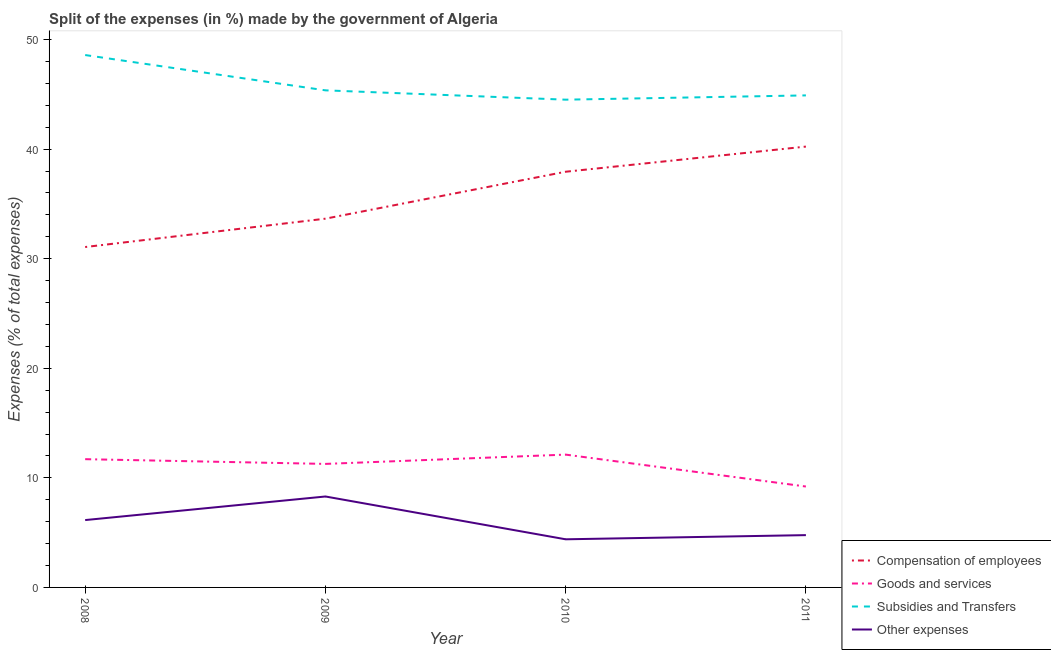How many different coloured lines are there?
Ensure brevity in your answer.  4. Is the number of lines equal to the number of legend labels?
Make the answer very short. Yes. What is the percentage of amount spent on other expenses in 2010?
Provide a succinct answer. 4.39. Across all years, what is the maximum percentage of amount spent on goods and services?
Provide a short and direct response. 12.12. Across all years, what is the minimum percentage of amount spent on goods and services?
Ensure brevity in your answer.  9.21. In which year was the percentage of amount spent on other expenses maximum?
Your response must be concise. 2009. In which year was the percentage of amount spent on compensation of employees minimum?
Your response must be concise. 2008. What is the total percentage of amount spent on compensation of employees in the graph?
Your response must be concise. 142.9. What is the difference between the percentage of amount spent on compensation of employees in 2008 and that in 2011?
Make the answer very short. -9.17. What is the difference between the percentage of amount spent on other expenses in 2008 and the percentage of amount spent on compensation of employees in 2010?
Offer a very short reply. -31.79. What is the average percentage of amount spent on subsidies per year?
Offer a terse response. 45.85. In the year 2011, what is the difference between the percentage of amount spent on subsidies and percentage of amount spent on other expenses?
Offer a very short reply. 40.13. What is the ratio of the percentage of amount spent on subsidies in 2009 to that in 2011?
Your answer should be very brief. 1.01. What is the difference between the highest and the second highest percentage of amount spent on compensation of employees?
Give a very brief answer. 2.29. What is the difference between the highest and the lowest percentage of amount spent on other expenses?
Provide a short and direct response. 3.91. Is it the case that in every year, the sum of the percentage of amount spent on compensation of employees and percentage of amount spent on goods and services is greater than the percentage of amount spent on subsidies?
Your response must be concise. No. Is the percentage of amount spent on goods and services strictly less than the percentage of amount spent on subsidies over the years?
Keep it short and to the point. Yes. Are the values on the major ticks of Y-axis written in scientific E-notation?
Offer a terse response. No. Does the graph contain any zero values?
Provide a succinct answer. No. Does the graph contain grids?
Your answer should be compact. No. What is the title of the graph?
Provide a succinct answer. Split of the expenses (in %) made by the government of Algeria. Does "Secondary" appear as one of the legend labels in the graph?
Your answer should be very brief. No. What is the label or title of the Y-axis?
Make the answer very short. Expenses (% of total expenses). What is the Expenses (% of total expenses) of Compensation of employees in 2008?
Your answer should be very brief. 31.07. What is the Expenses (% of total expenses) of Goods and services in 2008?
Your answer should be very brief. 11.7. What is the Expenses (% of total expenses) in Subsidies and Transfers in 2008?
Ensure brevity in your answer.  48.59. What is the Expenses (% of total expenses) in Other expenses in 2008?
Offer a very short reply. 6.15. What is the Expenses (% of total expenses) of Compensation of employees in 2009?
Your response must be concise. 33.66. What is the Expenses (% of total expenses) in Goods and services in 2009?
Provide a short and direct response. 11.27. What is the Expenses (% of total expenses) of Subsidies and Transfers in 2009?
Your answer should be compact. 45.37. What is the Expenses (% of total expenses) of Other expenses in 2009?
Your answer should be very brief. 8.3. What is the Expenses (% of total expenses) of Compensation of employees in 2010?
Provide a succinct answer. 37.94. What is the Expenses (% of total expenses) in Goods and services in 2010?
Your answer should be compact. 12.12. What is the Expenses (% of total expenses) of Subsidies and Transfers in 2010?
Offer a terse response. 44.52. What is the Expenses (% of total expenses) in Other expenses in 2010?
Your answer should be compact. 4.39. What is the Expenses (% of total expenses) in Compensation of employees in 2011?
Keep it short and to the point. 40.23. What is the Expenses (% of total expenses) in Goods and services in 2011?
Your answer should be compact. 9.21. What is the Expenses (% of total expenses) in Subsidies and Transfers in 2011?
Keep it short and to the point. 44.91. What is the Expenses (% of total expenses) in Other expenses in 2011?
Offer a very short reply. 4.77. Across all years, what is the maximum Expenses (% of total expenses) in Compensation of employees?
Your answer should be compact. 40.23. Across all years, what is the maximum Expenses (% of total expenses) of Goods and services?
Give a very brief answer. 12.12. Across all years, what is the maximum Expenses (% of total expenses) in Subsidies and Transfers?
Your response must be concise. 48.59. Across all years, what is the maximum Expenses (% of total expenses) of Other expenses?
Ensure brevity in your answer.  8.3. Across all years, what is the minimum Expenses (% of total expenses) of Compensation of employees?
Offer a terse response. 31.07. Across all years, what is the minimum Expenses (% of total expenses) of Goods and services?
Provide a succinct answer. 9.21. Across all years, what is the minimum Expenses (% of total expenses) of Subsidies and Transfers?
Keep it short and to the point. 44.52. Across all years, what is the minimum Expenses (% of total expenses) in Other expenses?
Provide a short and direct response. 4.39. What is the total Expenses (% of total expenses) in Compensation of employees in the graph?
Your answer should be very brief. 142.9. What is the total Expenses (% of total expenses) of Goods and services in the graph?
Make the answer very short. 44.31. What is the total Expenses (% of total expenses) in Subsidies and Transfers in the graph?
Your answer should be very brief. 183.38. What is the total Expenses (% of total expenses) in Other expenses in the graph?
Your answer should be compact. 23.61. What is the difference between the Expenses (% of total expenses) in Compensation of employees in 2008 and that in 2009?
Offer a terse response. -2.59. What is the difference between the Expenses (% of total expenses) in Goods and services in 2008 and that in 2009?
Keep it short and to the point. 0.43. What is the difference between the Expenses (% of total expenses) of Subsidies and Transfers in 2008 and that in 2009?
Provide a succinct answer. 3.22. What is the difference between the Expenses (% of total expenses) of Other expenses in 2008 and that in 2009?
Ensure brevity in your answer.  -2.15. What is the difference between the Expenses (% of total expenses) in Compensation of employees in 2008 and that in 2010?
Offer a terse response. -6.87. What is the difference between the Expenses (% of total expenses) in Goods and services in 2008 and that in 2010?
Provide a short and direct response. -0.42. What is the difference between the Expenses (% of total expenses) of Subsidies and Transfers in 2008 and that in 2010?
Your answer should be compact. 4.07. What is the difference between the Expenses (% of total expenses) in Other expenses in 2008 and that in 2010?
Your answer should be very brief. 1.75. What is the difference between the Expenses (% of total expenses) of Compensation of employees in 2008 and that in 2011?
Provide a succinct answer. -9.17. What is the difference between the Expenses (% of total expenses) in Goods and services in 2008 and that in 2011?
Your response must be concise. 2.5. What is the difference between the Expenses (% of total expenses) of Subsidies and Transfers in 2008 and that in 2011?
Provide a short and direct response. 3.68. What is the difference between the Expenses (% of total expenses) of Other expenses in 2008 and that in 2011?
Provide a succinct answer. 1.37. What is the difference between the Expenses (% of total expenses) in Compensation of employees in 2009 and that in 2010?
Your response must be concise. -4.28. What is the difference between the Expenses (% of total expenses) in Goods and services in 2009 and that in 2010?
Provide a short and direct response. -0.85. What is the difference between the Expenses (% of total expenses) in Subsidies and Transfers in 2009 and that in 2010?
Offer a very short reply. 0.85. What is the difference between the Expenses (% of total expenses) in Other expenses in 2009 and that in 2010?
Your answer should be very brief. 3.91. What is the difference between the Expenses (% of total expenses) of Compensation of employees in 2009 and that in 2011?
Your answer should be compact. -6.58. What is the difference between the Expenses (% of total expenses) in Goods and services in 2009 and that in 2011?
Your answer should be very brief. 2.06. What is the difference between the Expenses (% of total expenses) of Subsidies and Transfers in 2009 and that in 2011?
Make the answer very short. 0.46. What is the difference between the Expenses (% of total expenses) of Other expenses in 2009 and that in 2011?
Provide a succinct answer. 3.53. What is the difference between the Expenses (% of total expenses) of Compensation of employees in 2010 and that in 2011?
Make the answer very short. -2.29. What is the difference between the Expenses (% of total expenses) in Goods and services in 2010 and that in 2011?
Your answer should be compact. 2.91. What is the difference between the Expenses (% of total expenses) of Subsidies and Transfers in 2010 and that in 2011?
Offer a very short reply. -0.39. What is the difference between the Expenses (% of total expenses) of Other expenses in 2010 and that in 2011?
Give a very brief answer. -0.38. What is the difference between the Expenses (% of total expenses) in Compensation of employees in 2008 and the Expenses (% of total expenses) in Goods and services in 2009?
Provide a succinct answer. 19.79. What is the difference between the Expenses (% of total expenses) of Compensation of employees in 2008 and the Expenses (% of total expenses) of Subsidies and Transfers in 2009?
Your answer should be very brief. -14.3. What is the difference between the Expenses (% of total expenses) of Compensation of employees in 2008 and the Expenses (% of total expenses) of Other expenses in 2009?
Ensure brevity in your answer.  22.77. What is the difference between the Expenses (% of total expenses) of Goods and services in 2008 and the Expenses (% of total expenses) of Subsidies and Transfers in 2009?
Provide a succinct answer. -33.66. What is the difference between the Expenses (% of total expenses) in Goods and services in 2008 and the Expenses (% of total expenses) in Other expenses in 2009?
Provide a short and direct response. 3.41. What is the difference between the Expenses (% of total expenses) in Subsidies and Transfers in 2008 and the Expenses (% of total expenses) in Other expenses in 2009?
Make the answer very short. 40.29. What is the difference between the Expenses (% of total expenses) of Compensation of employees in 2008 and the Expenses (% of total expenses) of Goods and services in 2010?
Provide a succinct answer. 18.95. What is the difference between the Expenses (% of total expenses) in Compensation of employees in 2008 and the Expenses (% of total expenses) in Subsidies and Transfers in 2010?
Give a very brief answer. -13.45. What is the difference between the Expenses (% of total expenses) of Compensation of employees in 2008 and the Expenses (% of total expenses) of Other expenses in 2010?
Provide a short and direct response. 26.67. What is the difference between the Expenses (% of total expenses) of Goods and services in 2008 and the Expenses (% of total expenses) of Subsidies and Transfers in 2010?
Your answer should be compact. -32.81. What is the difference between the Expenses (% of total expenses) in Goods and services in 2008 and the Expenses (% of total expenses) in Other expenses in 2010?
Provide a succinct answer. 7.31. What is the difference between the Expenses (% of total expenses) in Subsidies and Transfers in 2008 and the Expenses (% of total expenses) in Other expenses in 2010?
Make the answer very short. 44.2. What is the difference between the Expenses (% of total expenses) in Compensation of employees in 2008 and the Expenses (% of total expenses) in Goods and services in 2011?
Ensure brevity in your answer.  21.86. What is the difference between the Expenses (% of total expenses) in Compensation of employees in 2008 and the Expenses (% of total expenses) in Subsidies and Transfers in 2011?
Keep it short and to the point. -13.84. What is the difference between the Expenses (% of total expenses) of Compensation of employees in 2008 and the Expenses (% of total expenses) of Other expenses in 2011?
Keep it short and to the point. 26.29. What is the difference between the Expenses (% of total expenses) in Goods and services in 2008 and the Expenses (% of total expenses) in Subsidies and Transfers in 2011?
Offer a very short reply. -33.2. What is the difference between the Expenses (% of total expenses) of Goods and services in 2008 and the Expenses (% of total expenses) of Other expenses in 2011?
Offer a terse response. 6.93. What is the difference between the Expenses (% of total expenses) of Subsidies and Transfers in 2008 and the Expenses (% of total expenses) of Other expenses in 2011?
Give a very brief answer. 43.82. What is the difference between the Expenses (% of total expenses) of Compensation of employees in 2009 and the Expenses (% of total expenses) of Goods and services in 2010?
Your answer should be very brief. 21.53. What is the difference between the Expenses (% of total expenses) in Compensation of employees in 2009 and the Expenses (% of total expenses) in Subsidies and Transfers in 2010?
Your response must be concise. -10.86. What is the difference between the Expenses (% of total expenses) of Compensation of employees in 2009 and the Expenses (% of total expenses) of Other expenses in 2010?
Keep it short and to the point. 29.26. What is the difference between the Expenses (% of total expenses) in Goods and services in 2009 and the Expenses (% of total expenses) in Subsidies and Transfers in 2010?
Provide a succinct answer. -33.24. What is the difference between the Expenses (% of total expenses) in Goods and services in 2009 and the Expenses (% of total expenses) in Other expenses in 2010?
Ensure brevity in your answer.  6.88. What is the difference between the Expenses (% of total expenses) of Subsidies and Transfers in 2009 and the Expenses (% of total expenses) of Other expenses in 2010?
Provide a succinct answer. 40.97. What is the difference between the Expenses (% of total expenses) in Compensation of employees in 2009 and the Expenses (% of total expenses) in Goods and services in 2011?
Offer a very short reply. 24.45. What is the difference between the Expenses (% of total expenses) in Compensation of employees in 2009 and the Expenses (% of total expenses) in Subsidies and Transfers in 2011?
Offer a very short reply. -11.25. What is the difference between the Expenses (% of total expenses) of Compensation of employees in 2009 and the Expenses (% of total expenses) of Other expenses in 2011?
Offer a terse response. 28.88. What is the difference between the Expenses (% of total expenses) of Goods and services in 2009 and the Expenses (% of total expenses) of Subsidies and Transfers in 2011?
Give a very brief answer. -33.63. What is the difference between the Expenses (% of total expenses) in Goods and services in 2009 and the Expenses (% of total expenses) in Other expenses in 2011?
Make the answer very short. 6.5. What is the difference between the Expenses (% of total expenses) of Subsidies and Transfers in 2009 and the Expenses (% of total expenses) of Other expenses in 2011?
Provide a succinct answer. 40.59. What is the difference between the Expenses (% of total expenses) of Compensation of employees in 2010 and the Expenses (% of total expenses) of Goods and services in 2011?
Your response must be concise. 28.73. What is the difference between the Expenses (% of total expenses) in Compensation of employees in 2010 and the Expenses (% of total expenses) in Subsidies and Transfers in 2011?
Keep it short and to the point. -6.97. What is the difference between the Expenses (% of total expenses) in Compensation of employees in 2010 and the Expenses (% of total expenses) in Other expenses in 2011?
Provide a succinct answer. 33.17. What is the difference between the Expenses (% of total expenses) in Goods and services in 2010 and the Expenses (% of total expenses) in Subsidies and Transfers in 2011?
Your answer should be compact. -32.79. What is the difference between the Expenses (% of total expenses) of Goods and services in 2010 and the Expenses (% of total expenses) of Other expenses in 2011?
Give a very brief answer. 7.35. What is the difference between the Expenses (% of total expenses) in Subsidies and Transfers in 2010 and the Expenses (% of total expenses) in Other expenses in 2011?
Offer a terse response. 39.74. What is the average Expenses (% of total expenses) of Compensation of employees per year?
Ensure brevity in your answer.  35.72. What is the average Expenses (% of total expenses) in Goods and services per year?
Your answer should be compact. 11.08. What is the average Expenses (% of total expenses) of Subsidies and Transfers per year?
Keep it short and to the point. 45.85. What is the average Expenses (% of total expenses) in Other expenses per year?
Your answer should be very brief. 5.9. In the year 2008, what is the difference between the Expenses (% of total expenses) of Compensation of employees and Expenses (% of total expenses) of Goods and services?
Your answer should be compact. 19.36. In the year 2008, what is the difference between the Expenses (% of total expenses) of Compensation of employees and Expenses (% of total expenses) of Subsidies and Transfers?
Your answer should be compact. -17.52. In the year 2008, what is the difference between the Expenses (% of total expenses) in Compensation of employees and Expenses (% of total expenses) in Other expenses?
Make the answer very short. 24.92. In the year 2008, what is the difference between the Expenses (% of total expenses) in Goods and services and Expenses (% of total expenses) in Subsidies and Transfers?
Your answer should be compact. -36.89. In the year 2008, what is the difference between the Expenses (% of total expenses) in Goods and services and Expenses (% of total expenses) in Other expenses?
Keep it short and to the point. 5.56. In the year 2008, what is the difference between the Expenses (% of total expenses) of Subsidies and Transfers and Expenses (% of total expenses) of Other expenses?
Provide a succinct answer. 42.44. In the year 2009, what is the difference between the Expenses (% of total expenses) in Compensation of employees and Expenses (% of total expenses) in Goods and services?
Ensure brevity in your answer.  22.38. In the year 2009, what is the difference between the Expenses (% of total expenses) of Compensation of employees and Expenses (% of total expenses) of Subsidies and Transfers?
Offer a terse response. -11.71. In the year 2009, what is the difference between the Expenses (% of total expenses) in Compensation of employees and Expenses (% of total expenses) in Other expenses?
Your answer should be very brief. 25.36. In the year 2009, what is the difference between the Expenses (% of total expenses) of Goods and services and Expenses (% of total expenses) of Subsidies and Transfers?
Provide a short and direct response. -34.09. In the year 2009, what is the difference between the Expenses (% of total expenses) of Goods and services and Expenses (% of total expenses) of Other expenses?
Keep it short and to the point. 2.97. In the year 2009, what is the difference between the Expenses (% of total expenses) in Subsidies and Transfers and Expenses (% of total expenses) in Other expenses?
Your answer should be very brief. 37.07. In the year 2010, what is the difference between the Expenses (% of total expenses) of Compensation of employees and Expenses (% of total expenses) of Goods and services?
Provide a short and direct response. 25.82. In the year 2010, what is the difference between the Expenses (% of total expenses) in Compensation of employees and Expenses (% of total expenses) in Subsidies and Transfers?
Make the answer very short. -6.58. In the year 2010, what is the difference between the Expenses (% of total expenses) in Compensation of employees and Expenses (% of total expenses) in Other expenses?
Your response must be concise. 33.55. In the year 2010, what is the difference between the Expenses (% of total expenses) in Goods and services and Expenses (% of total expenses) in Subsidies and Transfers?
Make the answer very short. -32.4. In the year 2010, what is the difference between the Expenses (% of total expenses) of Goods and services and Expenses (% of total expenses) of Other expenses?
Provide a succinct answer. 7.73. In the year 2010, what is the difference between the Expenses (% of total expenses) in Subsidies and Transfers and Expenses (% of total expenses) in Other expenses?
Make the answer very short. 40.12. In the year 2011, what is the difference between the Expenses (% of total expenses) in Compensation of employees and Expenses (% of total expenses) in Goods and services?
Your response must be concise. 31.03. In the year 2011, what is the difference between the Expenses (% of total expenses) of Compensation of employees and Expenses (% of total expenses) of Subsidies and Transfers?
Your response must be concise. -4.67. In the year 2011, what is the difference between the Expenses (% of total expenses) in Compensation of employees and Expenses (% of total expenses) in Other expenses?
Offer a very short reply. 35.46. In the year 2011, what is the difference between the Expenses (% of total expenses) of Goods and services and Expenses (% of total expenses) of Subsidies and Transfers?
Offer a very short reply. -35.7. In the year 2011, what is the difference between the Expenses (% of total expenses) in Goods and services and Expenses (% of total expenses) in Other expenses?
Your response must be concise. 4.44. In the year 2011, what is the difference between the Expenses (% of total expenses) of Subsidies and Transfers and Expenses (% of total expenses) of Other expenses?
Your response must be concise. 40.13. What is the ratio of the Expenses (% of total expenses) in Compensation of employees in 2008 to that in 2009?
Ensure brevity in your answer.  0.92. What is the ratio of the Expenses (% of total expenses) of Goods and services in 2008 to that in 2009?
Ensure brevity in your answer.  1.04. What is the ratio of the Expenses (% of total expenses) in Subsidies and Transfers in 2008 to that in 2009?
Keep it short and to the point. 1.07. What is the ratio of the Expenses (% of total expenses) in Other expenses in 2008 to that in 2009?
Your answer should be very brief. 0.74. What is the ratio of the Expenses (% of total expenses) in Compensation of employees in 2008 to that in 2010?
Provide a succinct answer. 0.82. What is the ratio of the Expenses (% of total expenses) of Goods and services in 2008 to that in 2010?
Offer a terse response. 0.97. What is the ratio of the Expenses (% of total expenses) of Subsidies and Transfers in 2008 to that in 2010?
Offer a terse response. 1.09. What is the ratio of the Expenses (% of total expenses) in Other expenses in 2008 to that in 2010?
Ensure brevity in your answer.  1.4. What is the ratio of the Expenses (% of total expenses) in Compensation of employees in 2008 to that in 2011?
Your response must be concise. 0.77. What is the ratio of the Expenses (% of total expenses) in Goods and services in 2008 to that in 2011?
Keep it short and to the point. 1.27. What is the ratio of the Expenses (% of total expenses) in Subsidies and Transfers in 2008 to that in 2011?
Your response must be concise. 1.08. What is the ratio of the Expenses (% of total expenses) in Other expenses in 2008 to that in 2011?
Offer a terse response. 1.29. What is the ratio of the Expenses (% of total expenses) in Compensation of employees in 2009 to that in 2010?
Keep it short and to the point. 0.89. What is the ratio of the Expenses (% of total expenses) of Goods and services in 2009 to that in 2010?
Make the answer very short. 0.93. What is the ratio of the Expenses (% of total expenses) in Subsidies and Transfers in 2009 to that in 2010?
Your answer should be very brief. 1.02. What is the ratio of the Expenses (% of total expenses) in Other expenses in 2009 to that in 2010?
Make the answer very short. 1.89. What is the ratio of the Expenses (% of total expenses) in Compensation of employees in 2009 to that in 2011?
Ensure brevity in your answer.  0.84. What is the ratio of the Expenses (% of total expenses) in Goods and services in 2009 to that in 2011?
Your response must be concise. 1.22. What is the ratio of the Expenses (% of total expenses) of Subsidies and Transfers in 2009 to that in 2011?
Give a very brief answer. 1.01. What is the ratio of the Expenses (% of total expenses) in Other expenses in 2009 to that in 2011?
Offer a very short reply. 1.74. What is the ratio of the Expenses (% of total expenses) of Compensation of employees in 2010 to that in 2011?
Your response must be concise. 0.94. What is the ratio of the Expenses (% of total expenses) of Goods and services in 2010 to that in 2011?
Keep it short and to the point. 1.32. What is the ratio of the Expenses (% of total expenses) of Other expenses in 2010 to that in 2011?
Provide a succinct answer. 0.92. What is the difference between the highest and the second highest Expenses (% of total expenses) of Compensation of employees?
Your answer should be very brief. 2.29. What is the difference between the highest and the second highest Expenses (% of total expenses) of Goods and services?
Make the answer very short. 0.42. What is the difference between the highest and the second highest Expenses (% of total expenses) in Subsidies and Transfers?
Your answer should be very brief. 3.22. What is the difference between the highest and the second highest Expenses (% of total expenses) in Other expenses?
Your response must be concise. 2.15. What is the difference between the highest and the lowest Expenses (% of total expenses) in Compensation of employees?
Provide a succinct answer. 9.17. What is the difference between the highest and the lowest Expenses (% of total expenses) in Goods and services?
Make the answer very short. 2.91. What is the difference between the highest and the lowest Expenses (% of total expenses) in Subsidies and Transfers?
Your answer should be compact. 4.07. What is the difference between the highest and the lowest Expenses (% of total expenses) in Other expenses?
Ensure brevity in your answer.  3.91. 